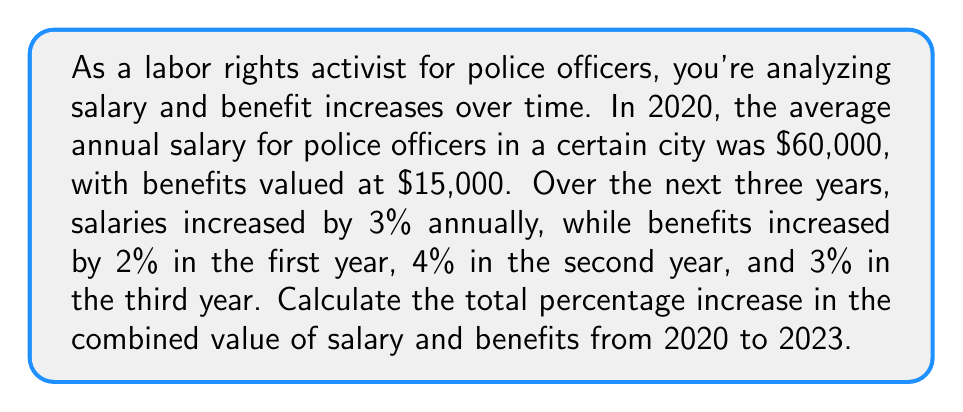Help me with this question. Let's break this down step-by-step:

1. Calculate the salary increase:
   Initial salary: $60,000
   After 3 years of 3% increase: $60,000 * $(1.03)^3$
   
   $60,000 * (1.03)^3 = 60,000 * 1.092727 = $65,563.62$

2. Calculate the benefits increase:
   Initial benefits: $15,000
   After 2% increase: $15,000 * 1.02 = $15,300
   After 4% increase: $15,300 * 1.04 = $15,912
   After 3% increase: $15,912 * 1.03 = $16,389.36$

3. Calculate the total initial value (salary + benefits) in 2020:
   $60,000 + $15,000 = $75,000$

4. Calculate the total final value (salary + benefits) in 2023:
   $65,563.62 + $16,389.36 = $81,952.98$

5. Calculate the percentage increase:
   Percentage increase = $\frac{\text{Increase}}{\text{Original}} * 100\%$
   
   $= \frac{81,952.98 - 75,000}{75,000} * 100\%$
   
   $= \frac{6,952.98}{75,000} * 100\%$
   
   $= 0.092706 * 100\% = 9.2706\%$
Answer: The total percentage increase in the combined value of salary and benefits from 2020 to 2023 is approximately 9.27%. 